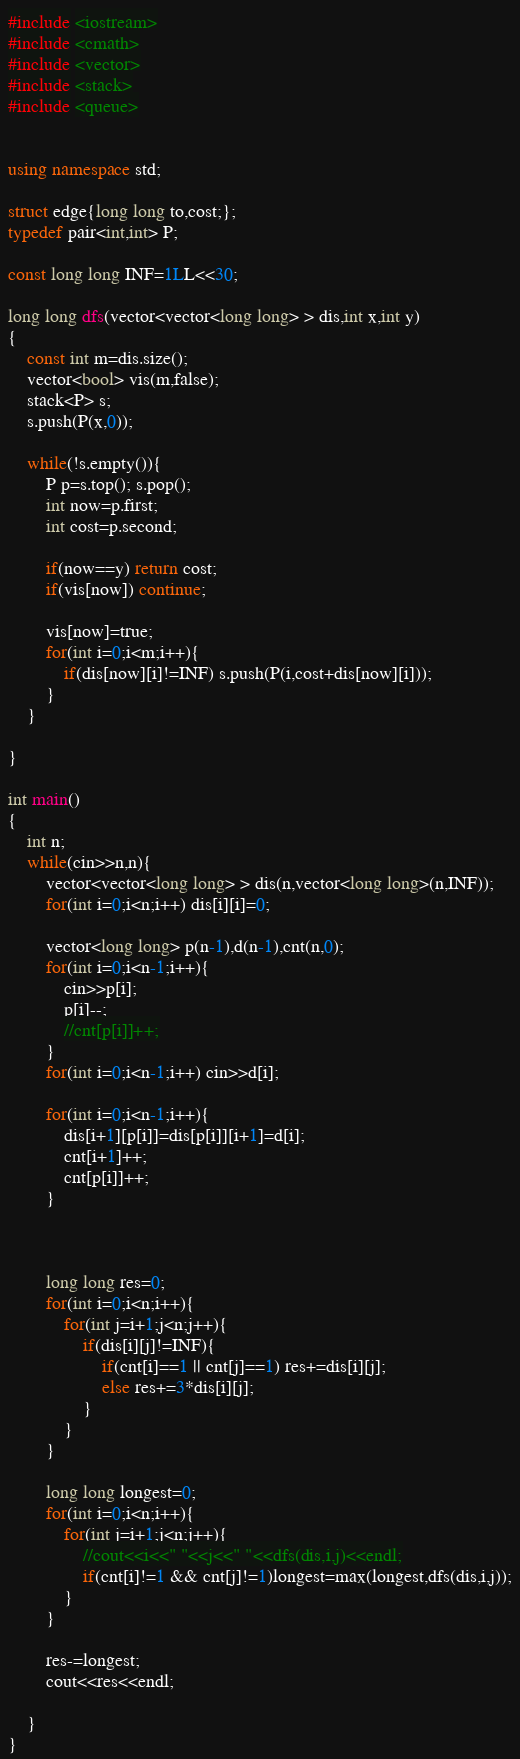Convert code to text. <code><loc_0><loc_0><loc_500><loc_500><_C++_>#include <iostream>
#include <cmath>
#include <vector>
#include <stack>
#include <queue>


using namespace std;

struct edge{long long to,cost;};
typedef pair<int,int> P;

const long long INF=1LL<<30;

long long dfs(vector<vector<long long> > dis,int x,int y)
{
	const int m=dis.size();
	vector<bool> vis(m,false);
	stack<P> s;
	s.push(P(x,0));
	
	while(!s.empty()){
		P p=s.top(); s.pop();
		int now=p.first;
		int cost=p.second;
		
		if(now==y) return cost;
		if(vis[now]) continue;
		
		vis[now]=true;
		for(int i=0;i<m;i++){
			if(dis[now][i]!=INF) s.push(P(i,cost+dis[now][i]));
		}
	}

}

int main()
{
	int n;
	while(cin>>n,n){
		vector<vector<long long> > dis(n,vector<long long>(n,INF));
		for(int i=0;i<n;i++) dis[i][i]=0;
		
		vector<long long> p(n-1),d(n-1),cnt(n,0);
		for(int i=0;i<n-1;i++){
			cin>>p[i];
			p[i]--;
			//cnt[p[i]]++;
		}
		for(int i=0;i<n-1;i++) cin>>d[i];
		
		for(int i=0;i<n-1;i++){
			dis[i+1][p[i]]=dis[p[i]][i+1]=d[i];
			cnt[i+1]++;
			cnt[p[i]]++;
		}


		
		long long res=0;
		for(int i=0;i<n;i++){
			for(int j=i+1;j<n;j++){
				if(dis[i][j]!=INF){
					if(cnt[i]==1 || cnt[j]==1) res+=dis[i][j];
					else res+=3*dis[i][j];
				}
			}
		}

		long long longest=0;		
		for(int i=0;i<n;i++){
			for(int j=i+1;j<n;j++){
				//cout<<i<<" "<<j<<" "<<dfs(dis,i,j)<<endl;
				if(cnt[i]!=1 && cnt[j]!=1)longest=max(longest,dfs(dis,i,j));
			}
		}

		res-=longest;
		cout<<res<<endl;
		
	}
}</code> 